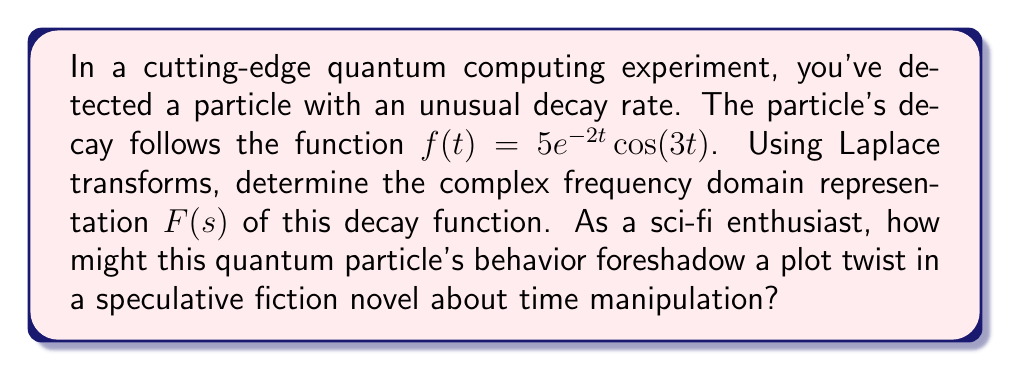Help me with this question. Let's approach this step-by-step using Laplace transforms:

1) The Laplace transform of $f(t)$ is defined as:

   $$F(s) = \int_0^{\infty} f(t)e^{-st} dt$$

2) Substituting our function:

   $$F(s) = \int_0^{\infty} 5e^{-2t} \cos(3t)e^{-st} dt$$

3) This can be rewritten as:

   $$F(s) = 5\int_0^{\infty} e^{-(s+2)t} \cos(3t) dt$$

4) We can use the Laplace transform property for $e^{at}\cos(bt)$:

   $$\mathcal{L}\{e^{at}\cos(bt)\} = \frac{s-a}{(s-a)^2 + b^2}$$

5) In our case, $a = -2$ and $b = 3$. Substituting:

   $$F(s) = 5 \cdot \frac{s-(-2)}{(s-(-2))^2 + 3^2}$$

6) Simplifying:

   $$F(s) = 5 \cdot \frac{s+2}{(s+2)^2 + 9}$$

7) Further simplifying:

   $$F(s) = \frac{5(s+2)}{s^2 + 4s + 13}$$

This complex frequency domain representation reveals the particle's decay characteristics in terms of complex frequencies, which could be interpreted as different time scales or dimensions in a sci-fi context.
Answer: $$F(s) = \frac{5(s+2)}{s^2 + 4s + 13}$$ 